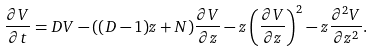<formula> <loc_0><loc_0><loc_500><loc_500>\frac { \partial V } { \partial t } = D V - ( ( D - 1 ) z + N ) \frac { \partial V } { \partial z } - z \left ( \frac { \partial V } { \partial z } \right ) ^ { 2 } - z \frac { \partial ^ { 2 } V } { \partial z ^ { 2 } } .</formula> 